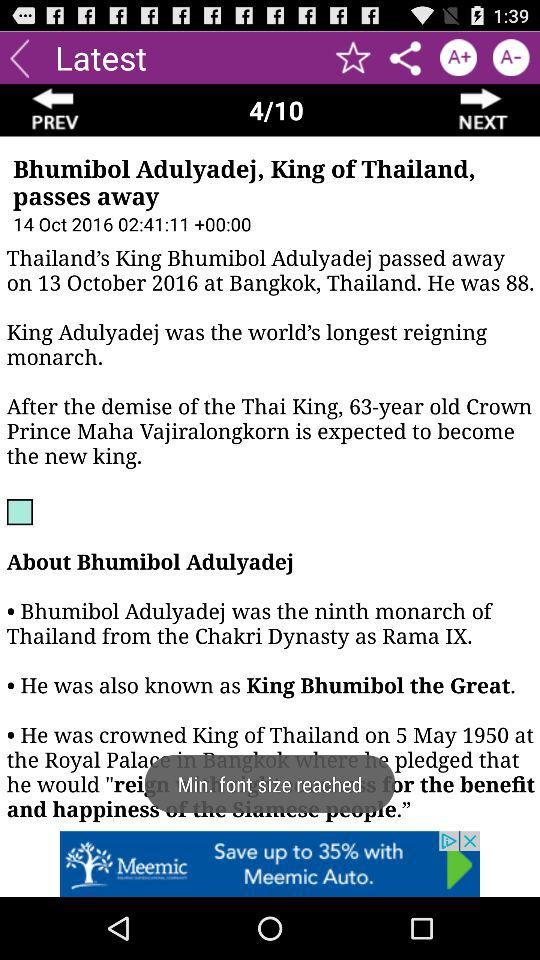How many pages in total are there? There are 10 pages in total. 